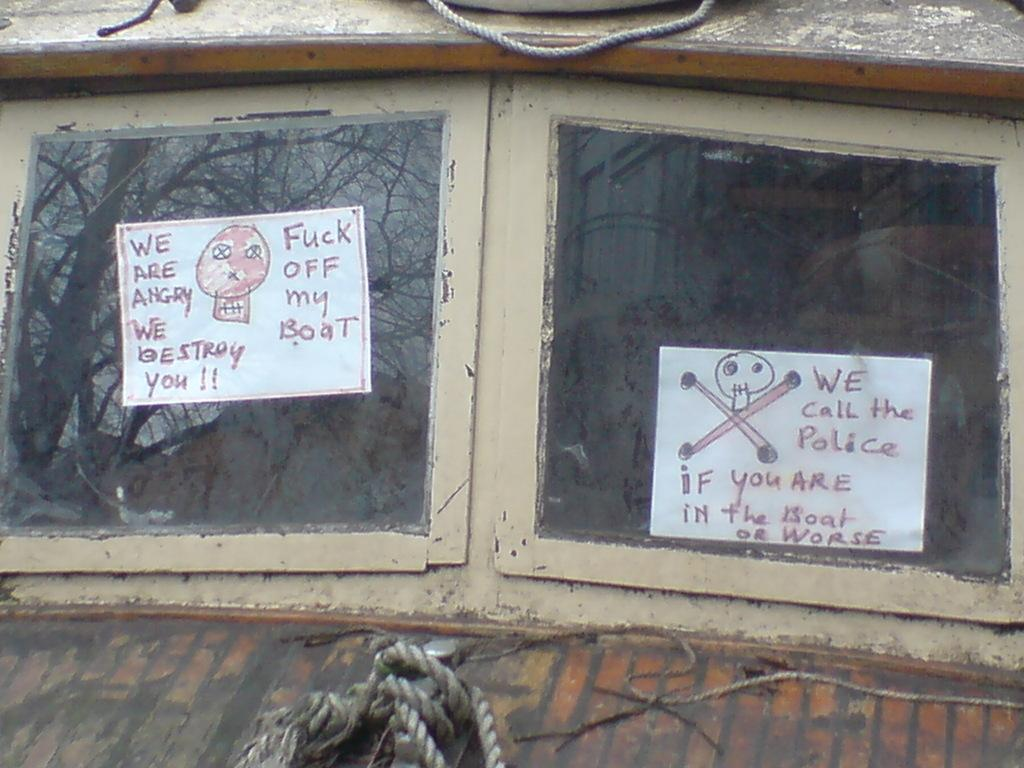What is located in the center of the image? There are windows in the center of the image. What is placed on the windows? Papers are stocked on the windows. What can be seen at the bottom of the image? There are tapes at the bottom of the image. What is present at the top of the image? There is a rope at the top of the image. How many competitors are participating in the snow competition in the image? There is no snow competition present in the image. What type of cent is visible in the image? There is no cent present in the image. 